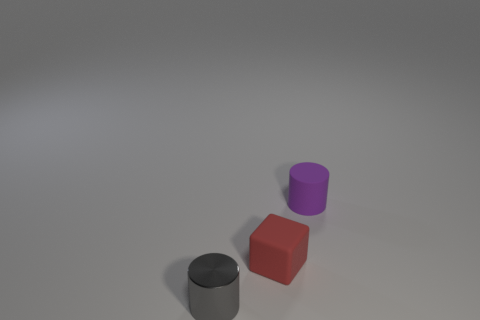Are there any tiny shiny things that are behind the cylinder that is on the left side of the small cylinder right of the small gray object?
Make the answer very short. No. There is a tiny cylinder behind the metallic thing; what is its material?
Provide a short and direct response. Rubber. Is the size of the red rubber thing the same as the purple cylinder?
Offer a very short reply. Yes. What is the color of the thing that is left of the matte cylinder and right of the small metal object?
Your response must be concise. Red. There is a tiny purple object that is made of the same material as the small red thing; what shape is it?
Provide a short and direct response. Cylinder. What number of things are both in front of the purple rubber cylinder and right of the gray cylinder?
Give a very brief answer. 1. There is a gray shiny thing; are there any objects behind it?
Make the answer very short. Yes. Do the thing on the right side of the red rubber thing and the matte object in front of the purple matte thing have the same shape?
Your answer should be compact. No. What number of things are either small metallic cylinders or small objects that are on the right side of the small metal thing?
Make the answer very short. 3. How many other things are there of the same shape as the red rubber object?
Make the answer very short. 0. 